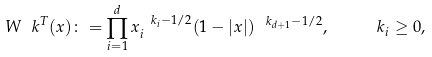<formula> <loc_0><loc_0><loc_500><loc_500>W _ { \ } k ^ { T } ( x ) \colon = \prod _ { i = 1 } ^ { d } x _ { i } ^ { \ k _ { i } - 1 / 2 } ( 1 - | x | ) ^ { \ k _ { d + 1 } - 1 / 2 } , \quad \ k _ { i } \geq 0 ,</formula> 